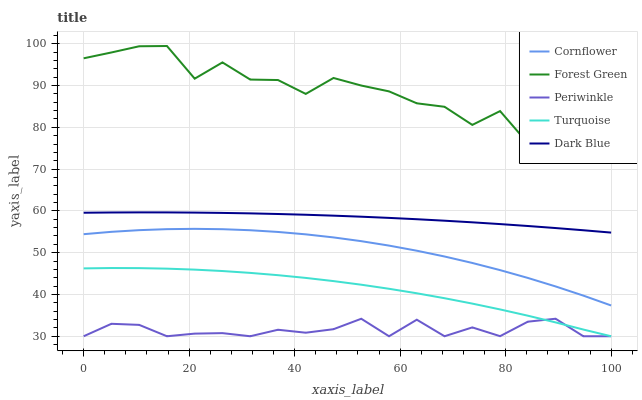Does Periwinkle have the minimum area under the curve?
Answer yes or no. Yes. Does Forest Green have the maximum area under the curve?
Answer yes or no. Yes. Does Forest Green have the minimum area under the curve?
Answer yes or no. No. Does Periwinkle have the maximum area under the curve?
Answer yes or no. No. Is Dark Blue the smoothest?
Answer yes or no. Yes. Is Forest Green the roughest?
Answer yes or no. Yes. Is Periwinkle the smoothest?
Answer yes or no. No. Is Periwinkle the roughest?
Answer yes or no. No. Does Periwinkle have the lowest value?
Answer yes or no. Yes. Does Forest Green have the lowest value?
Answer yes or no. No. Does Forest Green have the highest value?
Answer yes or no. Yes. Does Periwinkle have the highest value?
Answer yes or no. No. Is Cornflower less than Forest Green?
Answer yes or no. Yes. Is Forest Green greater than Turquoise?
Answer yes or no. Yes. Does Periwinkle intersect Turquoise?
Answer yes or no. Yes. Is Periwinkle less than Turquoise?
Answer yes or no. No. Is Periwinkle greater than Turquoise?
Answer yes or no. No. Does Cornflower intersect Forest Green?
Answer yes or no. No. 